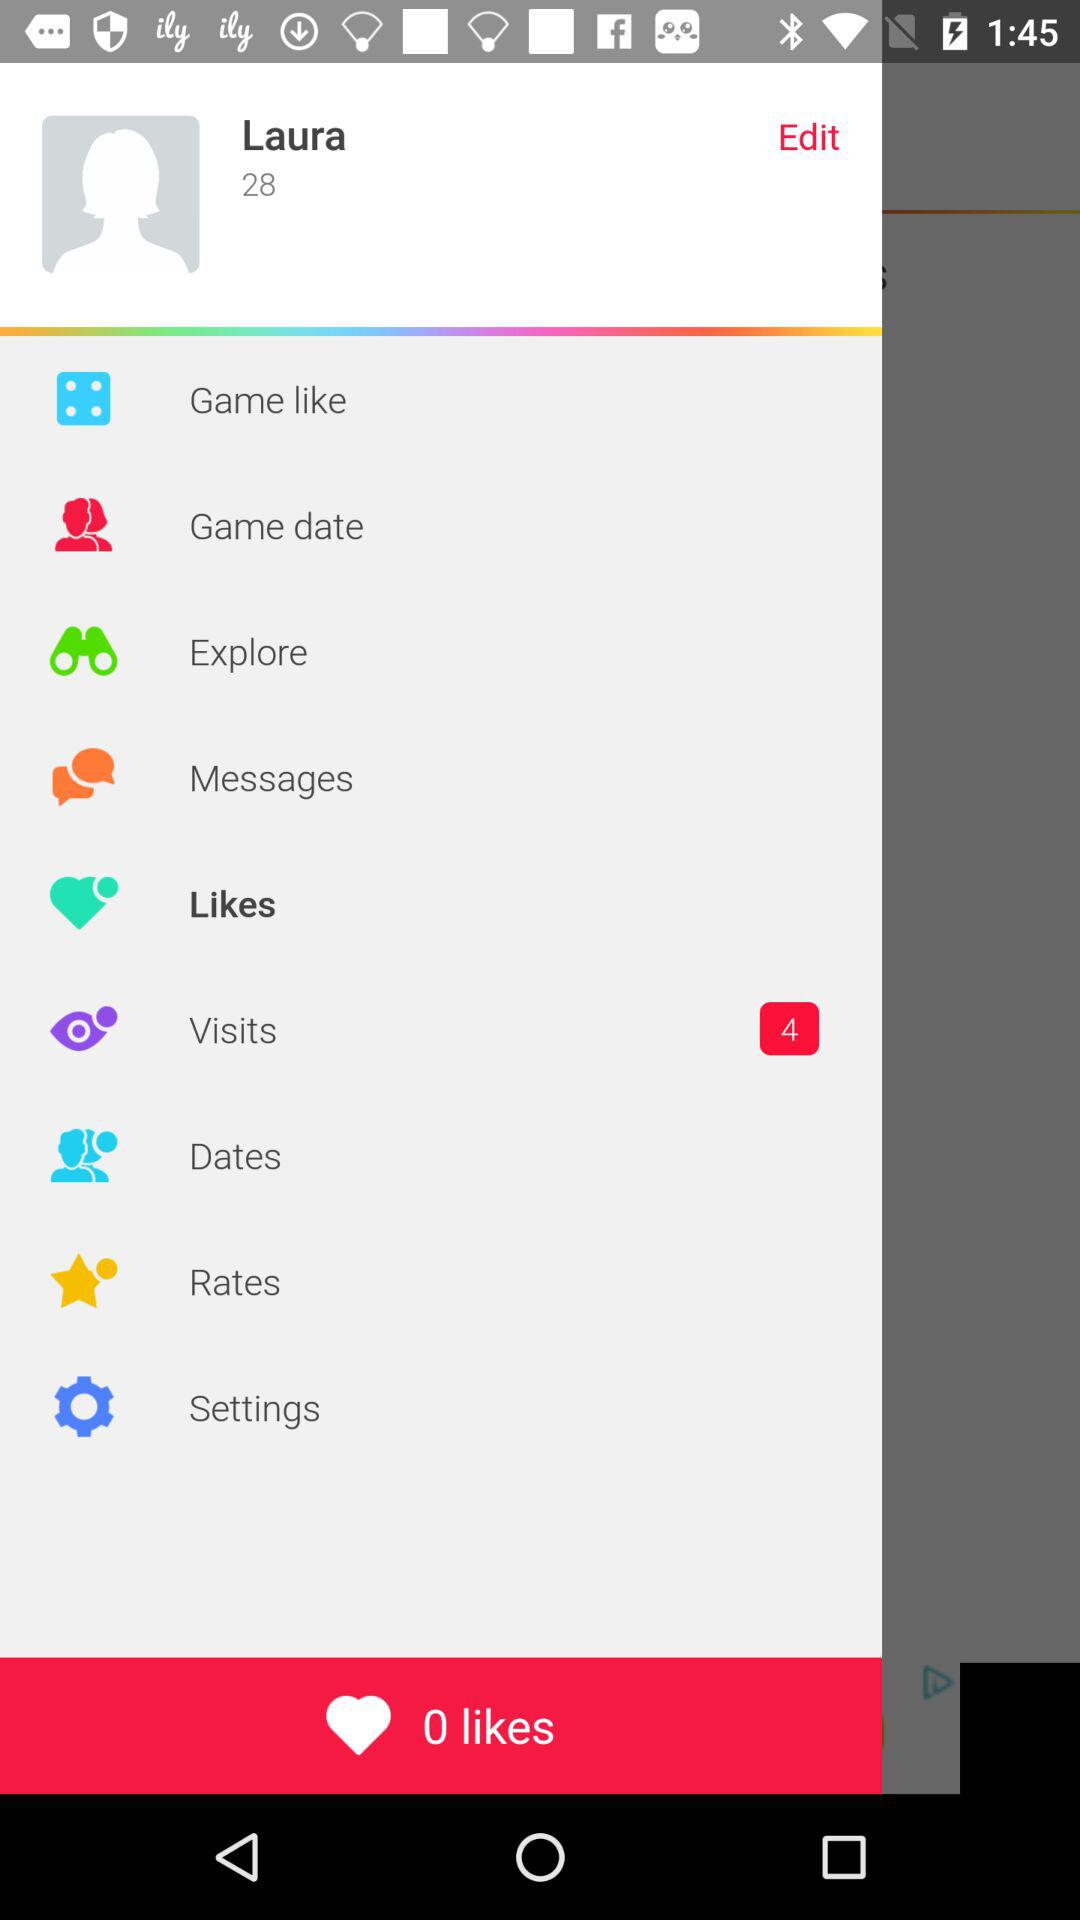What is the age? The age is 28 years old. 